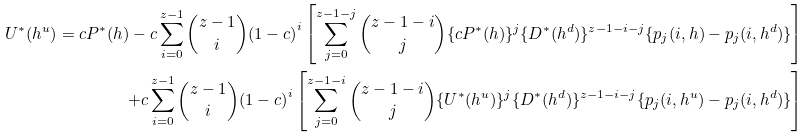Convert formula to latex. <formula><loc_0><loc_0><loc_500><loc_500>U ^ { * } ( h ^ { u } ) = c P ^ { * } ( h ) - c \sum _ { i = 0 } ^ { z - 1 } \binom { z - 1 } { i } { ( 1 - c ) } ^ { i } \left [ \sum _ { j = 0 } ^ { z - 1 - j } \binom { z - 1 - i } { j } \{ c P ^ { * } ( h ) \} ^ { j } \{ D ^ { * } ( h ^ { d } ) \} ^ { z - 1 - i - j } \{ p _ { j } ( i , h ) - p _ { j } ( i , h ^ { d } ) \} \right ] \\ + c \sum _ { i = 0 } ^ { z - 1 } \binom { z - 1 } { i } { ( 1 - c ) } ^ { i } \left [ \sum _ { j = 0 } ^ { z - 1 - i } \binom { z - 1 - i } { j } \{ U ^ { * } ( h ^ { u } ) \} ^ { j } \{ D ^ { * } ( h ^ { d } ) \} ^ { z - 1 - i - j } \{ p _ { j } ( i , h ^ { u } ) - p _ { j } ( i , h ^ { d } ) \} \right ]</formula> 